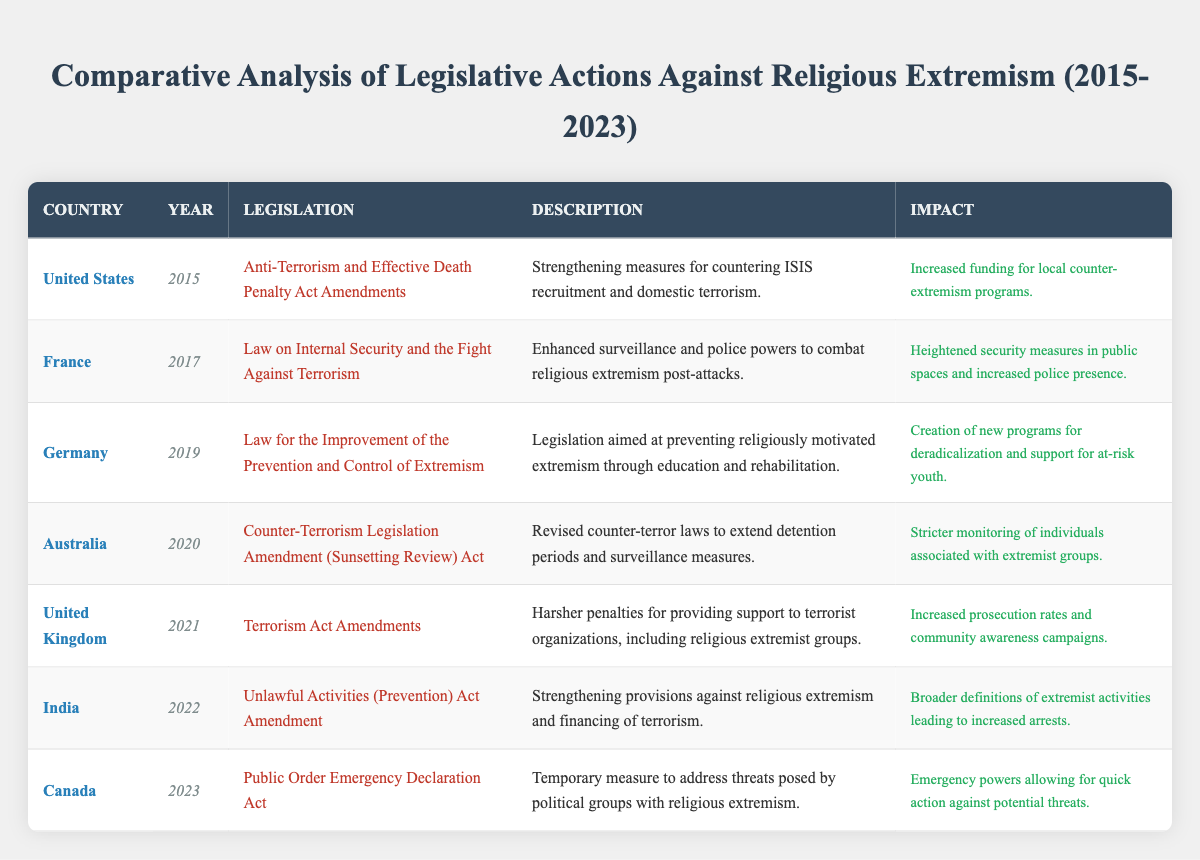What country implemented legislation against religious extremism in 2017? The table indicates that France took legislative action in 2017 with the "Law on Internal Security and the Fight Against Terrorism."
Answer: France Which legislation was enacted in Canada in 2023? According to the table, Canada enacted the "Public Order Emergency Declaration Act" in 2023.
Answer: Public Order Emergency Declaration Act How many countries took legislative actions against religious extremism between 2015 to 2023? By counting the unique countries listed in the table, there are seven countries: United States, France, Germany, Australia, United Kingdom, India, and Canada.
Answer: 7 What was the impact of India's legislative action in 2022? The table notes that the impact of India's "Unlawful Activities (Prevention) Act Amendment" was broader definitions of extremist activities leading to increased arrests.
Answer: Increased arrests Which country has legislation focusing on education and rehabilitation to counteract extremism? The data shows that Germany's 2019 legislation, "Law for the Improvement of the Prevention and Control of Extremism," specifically aims at prevention through education and rehabilitation.
Answer: Germany What is the year with the highest mention of legislative actions in the table, and how many occurred that year? By reviewing the table, each year only has one piece of legislation listed except for 2023, which does not have any legislation. Thus, no single year stands out with multiple mentions.
Answer: 0 Did Australia have a piece of legislation related to religious extremism after 2018? Yes, the table shows that Australia enacted the "Counter-Terrorism Legislation Amendment (Sunsetting Review) Act" in 2020.
Answer: Yes What was the primary goal of the legislation implemented by the United States in 2015? The table states that the goal of the "Anti-Terrorism and Effective Death Penalty Act Amendments" was to strengthen measures for countering ISIS recruitment and domestic terrorism.
Answer: Countering ISIS recruitment and domestic terrorism What type of legislative action did the United Kingdom take in 2021 regarding religious extremism? The United Kingdom's legislative action in 2021 involved harsher penalties for supporting terrorist organizations, including religious extremist groups, as noted in the "Terrorism Act Amendments."
Answer: Harsher penalties 